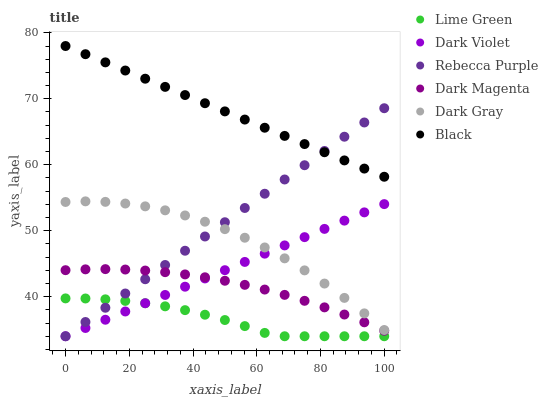Does Lime Green have the minimum area under the curve?
Answer yes or no. Yes. Does Black have the maximum area under the curve?
Answer yes or no. Yes. Does Dark Violet have the minimum area under the curve?
Answer yes or no. No. Does Dark Violet have the maximum area under the curve?
Answer yes or no. No. Is Black the smoothest?
Answer yes or no. Yes. Is Dark Gray the roughest?
Answer yes or no. Yes. Is Dark Violet the smoothest?
Answer yes or no. No. Is Dark Violet the roughest?
Answer yes or no. No. Does Dark Violet have the lowest value?
Answer yes or no. Yes. Does Dark Gray have the lowest value?
Answer yes or no. No. Does Black have the highest value?
Answer yes or no. Yes. Does Dark Violet have the highest value?
Answer yes or no. No. Is Lime Green less than Black?
Answer yes or no. Yes. Is Dark Gray greater than Lime Green?
Answer yes or no. Yes. Does Dark Violet intersect Rebecca Purple?
Answer yes or no. Yes. Is Dark Violet less than Rebecca Purple?
Answer yes or no. No. Is Dark Violet greater than Rebecca Purple?
Answer yes or no. No. Does Lime Green intersect Black?
Answer yes or no. No. 